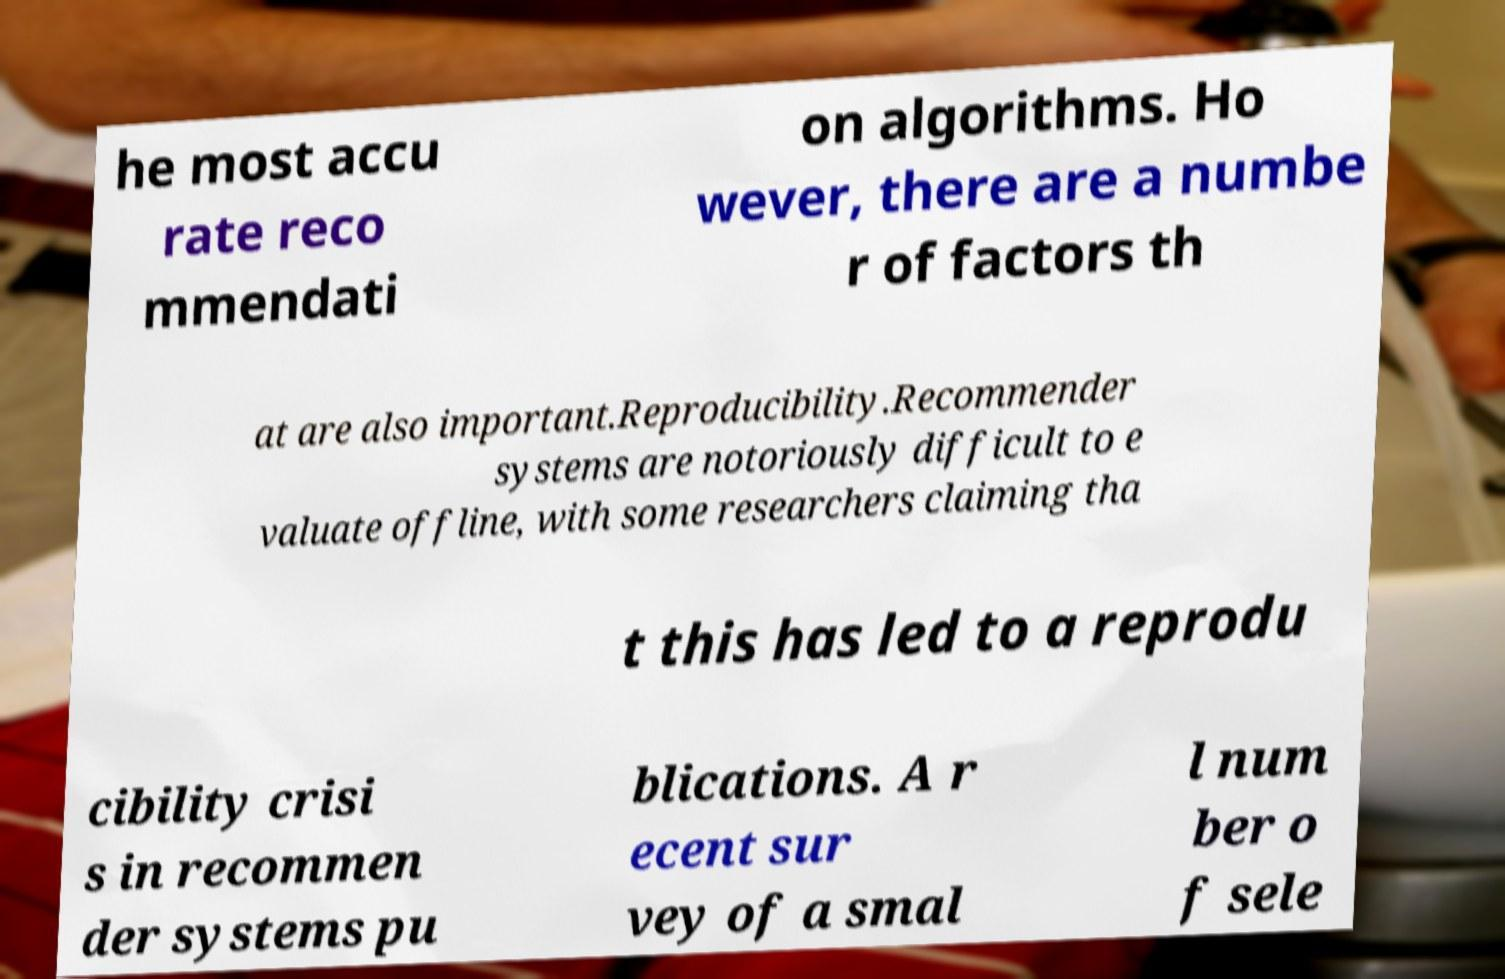Can you accurately transcribe the text from the provided image for me? he most accu rate reco mmendati on algorithms. Ho wever, there are a numbe r of factors th at are also important.Reproducibility.Recommender systems are notoriously difficult to e valuate offline, with some researchers claiming tha t this has led to a reprodu cibility crisi s in recommen der systems pu blications. A r ecent sur vey of a smal l num ber o f sele 